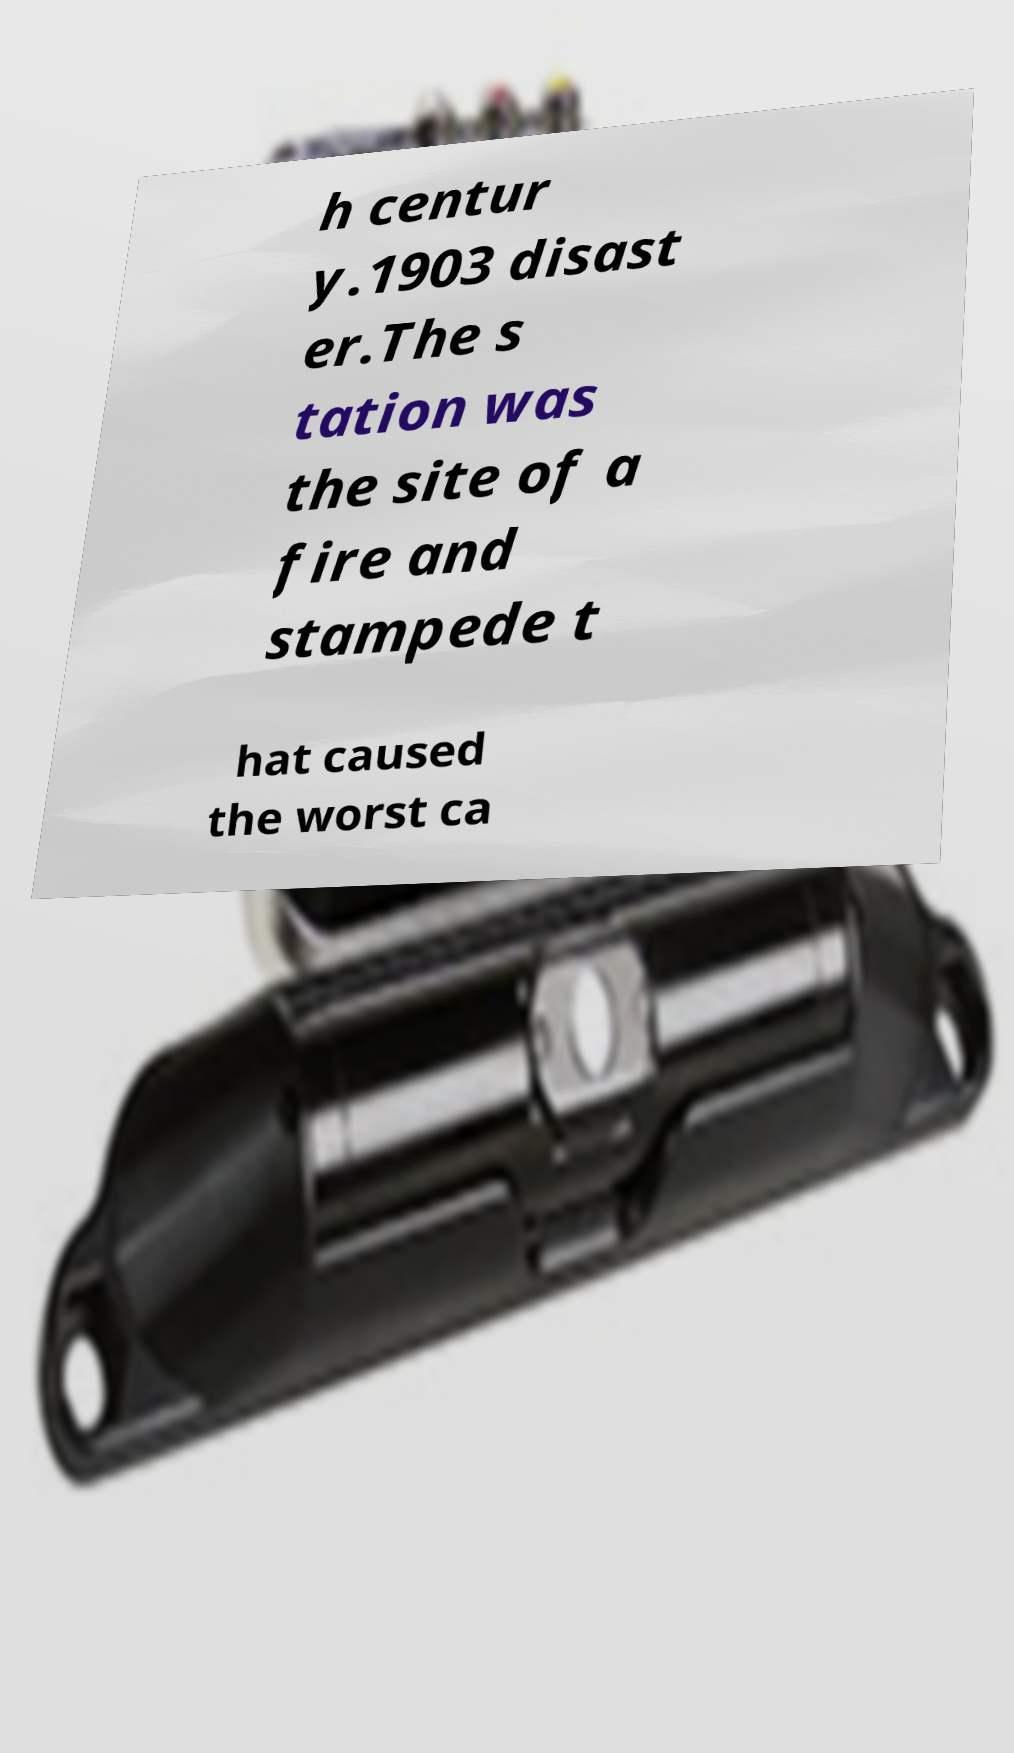Could you extract and type out the text from this image? h centur y.1903 disast er.The s tation was the site of a fire and stampede t hat caused the worst ca 